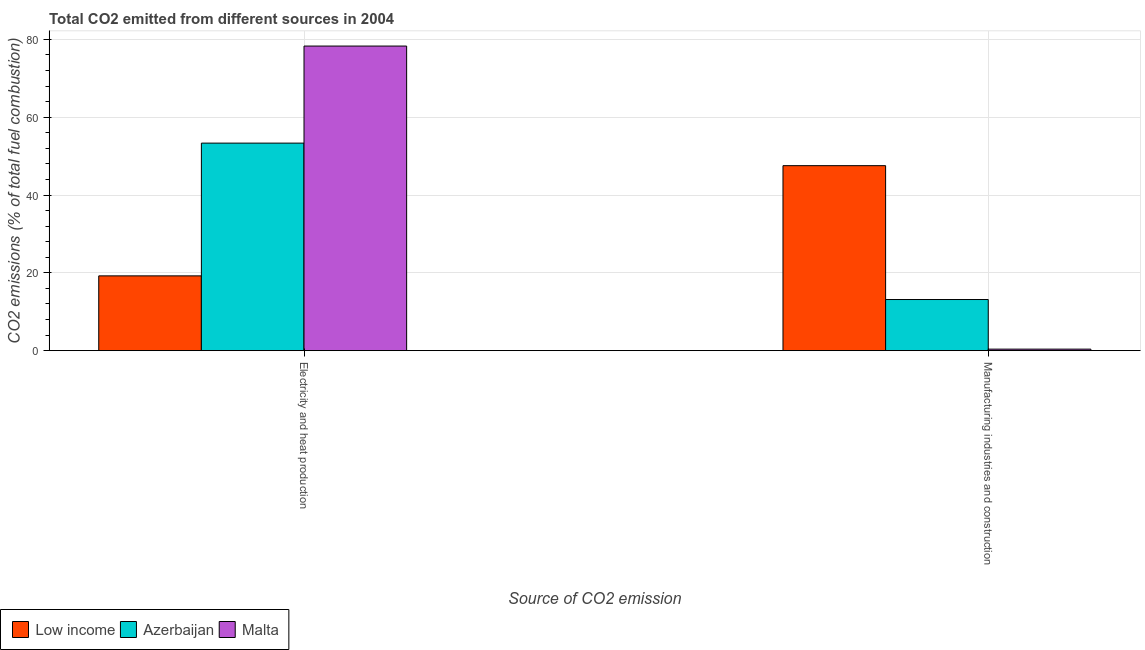How many different coloured bars are there?
Your response must be concise. 3. Are the number of bars per tick equal to the number of legend labels?
Make the answer very short. Yes. Are the number of bars on each tick of the X-axis equal?
Your response must be concise. Yes. What is the label of the 1st group of bars from the left?
Make the answer very short. Electricity and heat production. What is the co2 emissions due to manufacturing industries in Low income?
Offer a very short reply. 47.55. Across all countries, what is the maximum co2 emissions due to electricity and heat production?
Keep it short and to the point. 78.29. Across all countries, what is the minimum co2 emissions due to electricity and heat production?
Keep it short and to the point. 19.22. In which country was the co2 emissions due to electricity and heat production maximum?
Your answer should be very brief. Malta. In which country was the co2 emissions due to manufacturing industries minimum?
Your response must be concise. Malta. What is the total co2 emissions due to electricity and heat production in the graph?
Offer a terse response. 150.86. What is the difference between the co2 emissions due to electricity and heat production in Low income and that in Malta?
Give a very brief answer. -59.07. What is the difference between the co2 emissions due to manufacturing industries in Low income and the co2 emissions due to electricity and heat production in Azerbaijan?
Offer a very short reply. -5.8. What is the average co2 emissions due to manufacturing industries per country?
Offer a very short reply. 20.36. What is the difference between the co2 emissions due to manufacturing industries and co2 emissions due to electricity and heat production in Low income?
Your answer should be compact. 28.33. What is the ratio of the co2 emissions due to electricity and heat production in Low income to that in Azerbaijan?
Your response must be concise. 0.36. What does the 2nd bar from the left in Manufacturing industries and construction represents?
Provide a short and direct response. Azerbaijan. What does the 1st bar from the right in Electricity and heat production represents?
Offer a terse response. Malta. What is the difference between two consecutive major ticks on the Y-axis?
Give a very brief answer. 20. How many legend labels are there?
Offer a very short reply. 3. What is the title of the graph?
Provide a succinct answer. Total CO2 emitted from different sources in 2004. Does "El Salvador" appear as one of the legend labels in the graph?
Provide a succinct answer. No. What is the label or title of the X-axis?
Offer a very short reply. Source of CO2 emission. What is the label or title of the Y-axis?
Make the answer very short. CO2 emissions (% of total fuel combustion). What is the CO2 emissions (% of total fuel combustion) in Low income in Electricity and heat production?
Keep it short and to the point. 19.22. What is the CO2 emissions (% of total fuel combustion) of Azerbaijan in Electricity and heat production?
Your answer should be very brief. 53.34. What is the CO2 emissions (% of total fuel combustion) in Malta in Electricity and heat production?
Make the answer very short. 78.29. What is the CO2 emissions (% of total fuel combustion) in Low income in Manufacturing industries and construction?
Your answer should be very brief. 47.55. What is the CO2 emissions (% of total fuel combustion) of Azerbaijan in Manufacturing industries and construction?
Give a very brief answer. 13.14. What is the CO2 emissions (% of total fuel combustion) of Malta in Manufacturing industries and construction?
Give a very brief answer. 0.39. Across all Source of CO2 emission, what is the maximum CO2 emissions (% of total fuel combustion) of Low income?
Provide a short and direct response. 47.55. Across all Source of CO2 emission, what is the maximum CO2 emissions (% of total fuel combustion) of Azerbaijan?
Provide a succinct answer. 53.34. Across all Source of CO2 emission, what is the maximum CO2 emissions (% of total fuel combustion) of Malta?
Provide a short and direct response. 78.29. Across all Source of CO2 emission, what is the minimum CO2 emissions (% of total fuel combustion) in Low income?
Your answer should be compact. 19.22. Across all Source of CO2 emission, what is the minimum CO2 emissions (% of total fuel combustion) of Azerbaijan?
Your answer should be compact. 13.14. Across all Source of CO2 emission, what is the minimum CO2 emissions (% of total fuel combustion) in Malta?
Make the answer very short. 0.39. What is the total CO2 emissions (% of total fuel combustion) of Low income in the graph?
Provide a short and direct response. 66.77. What is the total CO2 emissions (% of total fuel combustion) in Azerbaijan in the graph?
Provide a succinct answer. 66.48. What is the total CO2 emissions (% of total fuel combustion) of Malta in the graph?
Give a very brief answer. 78.68. What is the difference between the CO2 emissions (% of total fuel combustion) of Low income in Electricity and heat production and that in Manufacturing industries and construction?
Provide a succinct answer. -28.33. What is the difference between the CO2 emissions (% of total fuel combustion) in Azerbaijan in Electricity and heat production and that in Manufacturing industries and construction?
Offer a very short reply. 40.2. What is the difference between the CO2 emissions (% of total fuel combustion) in Malta in Electricity and heat production and that in Manufacturing industries and construction?
Ensure brevity in your answer.  77.91. What is the difference between the CO2 emissions (% of total fuel combustion) in Low income in Electricity and heat production and the CO2 emissions (% of total fuel combustion) in Azerbaijan in Manufacturing industries and construction?
Provide a short and direct response. 6.08. What is the difference between the CO2 emissions (% of total fuel combustion) in Low income in Electricity and heat production and the CO2 emissions (% of total fuel combustion) in Malta in Manufacturing industries and construction?
Provide a succinct answer. 18.83. What is the difference between the CO2 emissions (% of total fuel combustion) in Azerbaijan in Electricity and heat production and the CO2 emissions (% of total fuel combustion) in Malta in Manufacturing industries and construction?
Give a very brief answer. 52.96. What is the average CO2 emissions (% of total fuel combustion) of Low income per Source of CO2 emission?
Make the answer very short. 33.38. What is the average CO2 emissions (% of total fuel combustion) in Azerbaijan per Source of CO2 emission?
Your response must be concise. 33.24. What is the average CO2 emissions (% of total fuel combustion) of Malta per Source of CO2 emission?
Your response must be concise. 39.34. What is the difference between the CO2 emissions (% of total fuel combustion) of Low income and CO2 emissions (% of total fuel combustion) of Azerbaijan in Electricity and heat production?
Your answer should be very brief. -34.12. What is the difference between the CO2 emissions (% of total fuel combustion) in Low income and CO2 emissions (% of total fuel combustion) in Malta in Electricity and heat production?
Your answer should be very brief. -59.07. What is the difference between the CO2 emissions (% of total fuel combustion) in Azerbaijan and CO2 emissions (% of total fuel combustion) in Malta in Electricity and heat production?
Offer a terse response. -24.95. What is the difference between the CO2 emissions (% of total fuel combustion) in Low income and CO2 emissions (% of total fuel combustion) in Azerbaijan in Manufacturing industries and construction?
Provide a short and direct response. 34.41. What is the difference between the CO2 emissions (% of total fuel combustion) in Low income and CO2 emissions (% of total fuel combustion) in Malta in Manufacturing industries and construction?
Your answer should be very brief. 47.16. What is the difference between the CO2 emissions (% of total fuel combustion) in Azerbaijan and CO2 emissions (% of total fuel combustion) in Malta in Manufacturing industries and construction?
Provide a short and direct response. 12.75. What is the ratio of the CO2 emissions (% of total fuel combustion) of Low income in Electricity and heat production to that in Manufacturing industries and construction?
Offer a very short reply. 0.4. What is the ratio of the CO2 emissions (% of total fuel combustion) in Azerbaijan in Electricity and heat production to that in Manufacturing industries and construction?
Offer a terse response. 4.06. What is the ratio of the CO2 emissions (% of total fuel combustion) of Malta in Electricity and heat production to that in Manufacturing industries and construction?
Keep it short and to the point. 202. What is the difference between the highest and the second highest CO2 emissions (% of total fuel combustion) in Low income?
Your response must be concise. 28.33. What is the difference between the highest and the second highest CO2 emissions (% of total fuel combustion) in Azerbaijan?
Offer a very short reply. 40.2. What is the difference between the highest and the second highest CO2 emissions (% of total fuel combustion) of Malta?
Your response must be concise. 77.91. What is the difference between the highest and the lowest CO2 emissions (% of total fuel combustion) in Low income?
Offer a very short reply. 28.33. What is the difference between the highest and the lowest CO2 emissions (% of total fuel combustion) in Azerbaijan?
Provide a short and direct response. 40.2. What is the difference between the highest and the lowest CO2 emissions (% of total fuel combustion) of Malta?
Your answer should be compact. 77.91. 